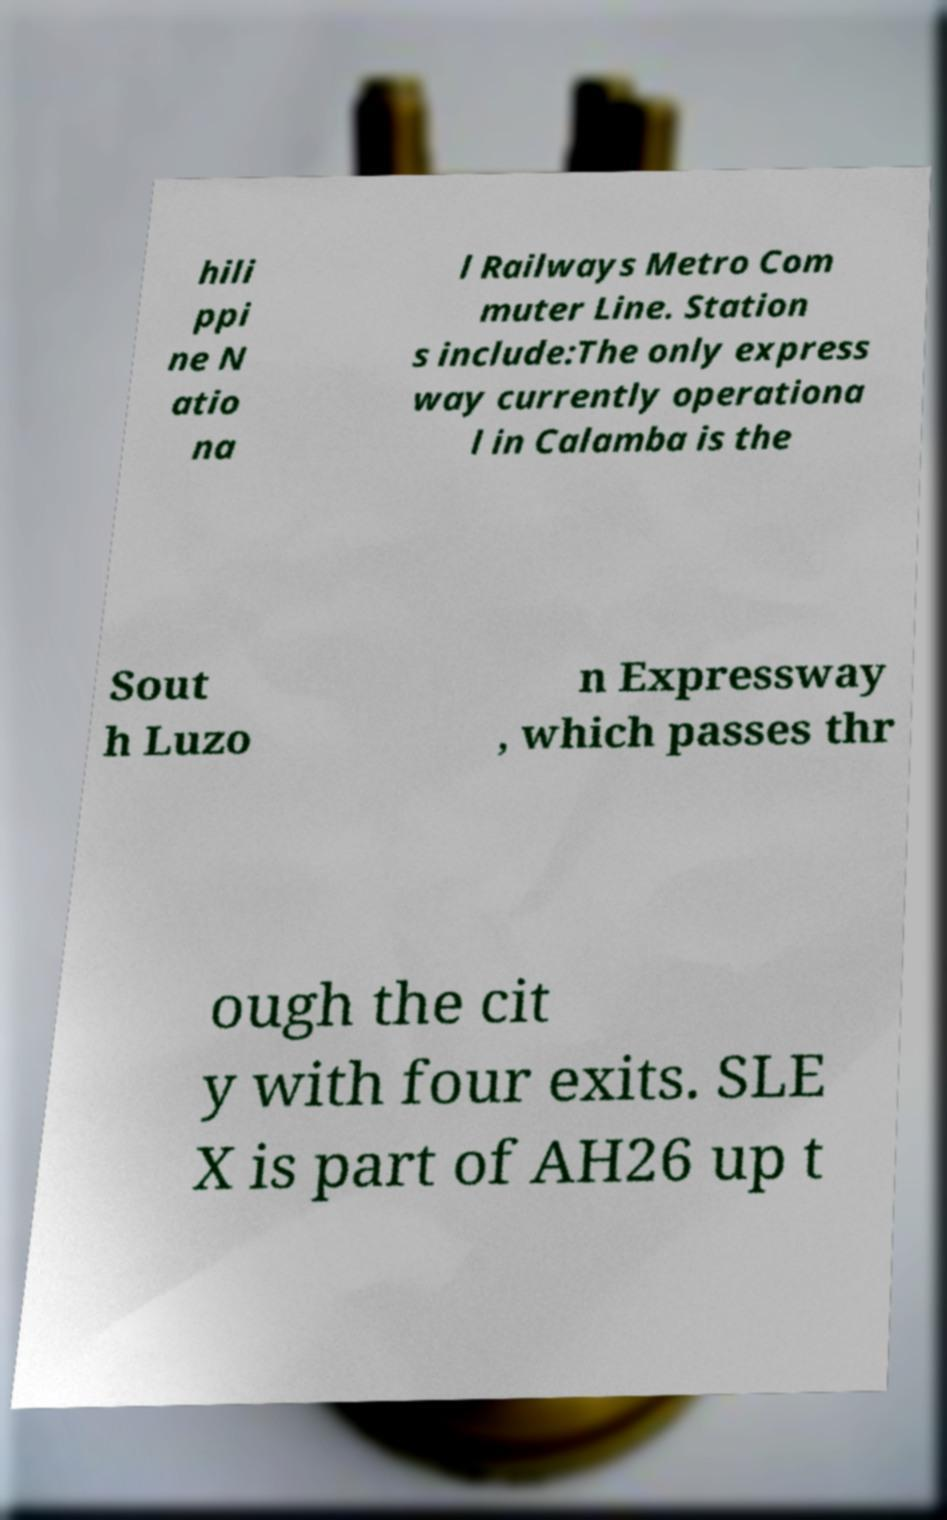For documentation purposes, I need the text within this image transcribed. Could you provide that? hili ppi ne N atio na l Railways Metro Com muter Line. Station s include:The only express way currently operationa l in Calamba is the Sout h Luzo n Expressway , which passes thr ough the cit y with four exits. SLE X is part of AH26 up t 